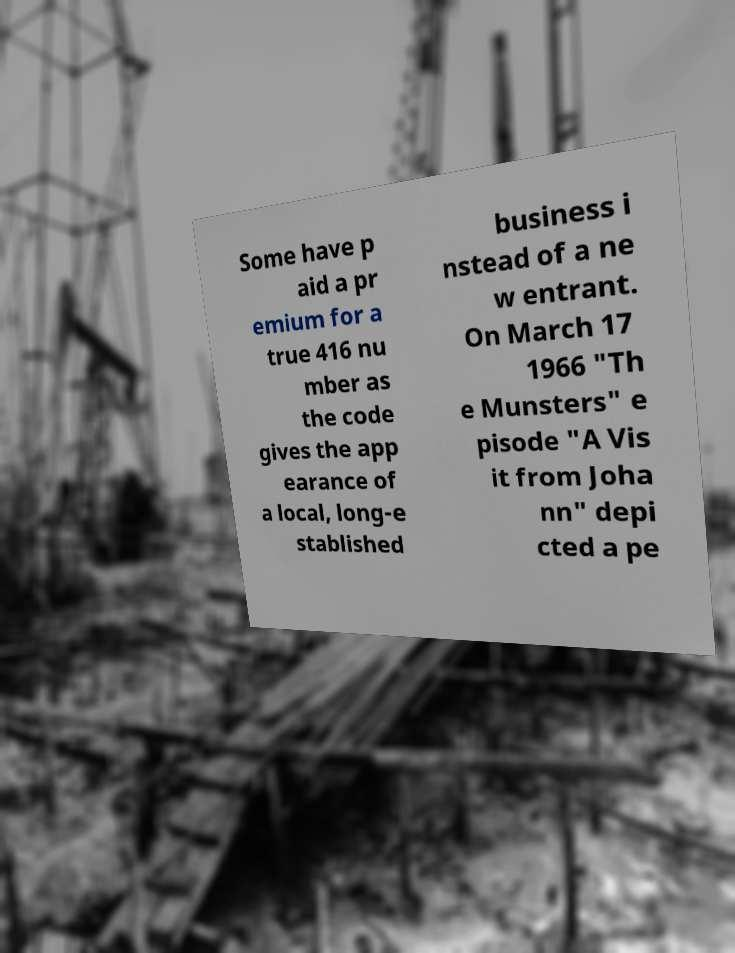There's text embedded in this image that I need extracted. Can you transcribe it verbatim? Some have p aid a pr emium for a true 416 nu mber as the code gives the app earance of a local, long-e stablished business i nstead of a ne w entrant. On March 17 1966 "Th e Munsters" e pisode "A Vis it from Joha nn" depi cted a pe 